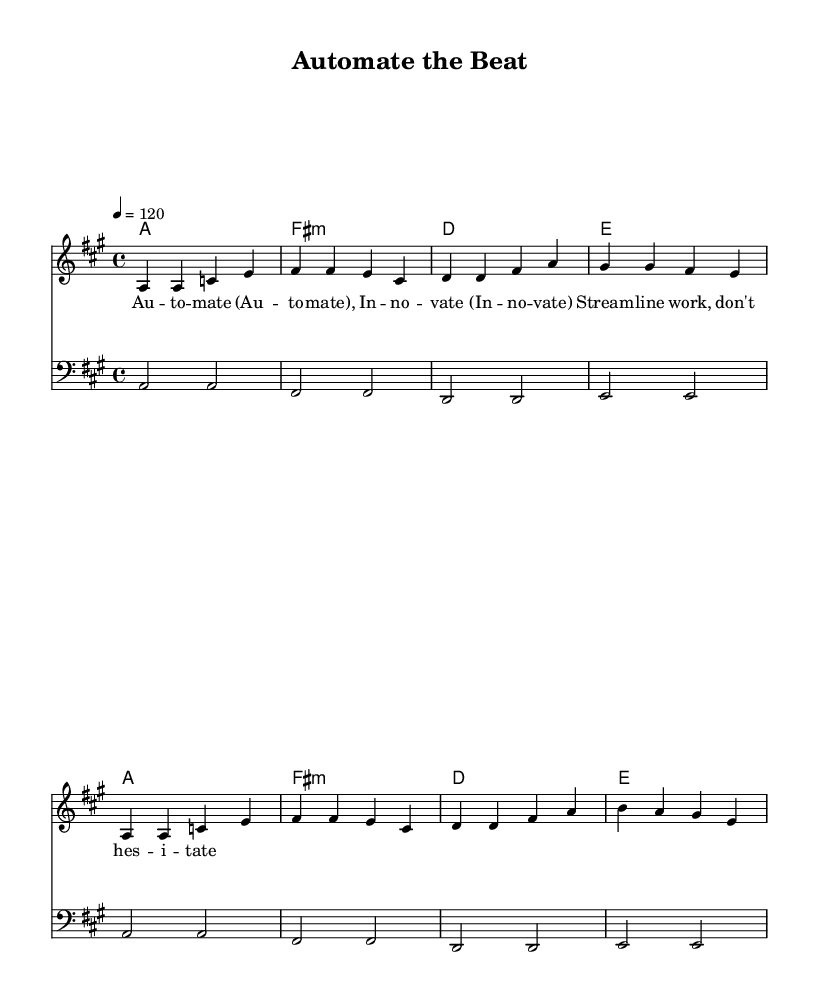What is the key signature of this music? The key signature is indicated by the notes present. In this case, the key of A major contains three sharps: F#, C#, and G#. Therefore, we conclude that the key signature is A major.
Answer: A major What is the time signature of this music? The time signature is typically found at the beginning of the score, written as a fraction. Here, it is shown as 4/4, meaning there are four beats per measure.
Answer: 4/4 What tempo marking is used in this music? The tempo is given in beats per minute, indicated in the score as a number. In this case, the tempo marking is 120, meaning the music should be played at 120 beats per minute.
Answer: 120 How many measures are in the melody section? To find the number of measures, we count the divisions between vertical lines in the melody. There are a total of 8 measures in the melody part of the score.
Answer: 8 Which chord appears first in the harmony section? The harmony section lists the chords, starting with the first one placed in the first measure. The first chord is A major, as indicated by the symbol at the start of the score.
Answer: A What word describes the overall theme of this disco song? The words presented in the lyric section hint at the subject of the song, focusing on themes of automation and innovation. Therefore, the theme of this song can be summarized as "automation."
Answer: automation What is the role of the bass in this piece? The bass typically plays a fundamental role in providing the harmonic foundation in music. In this piece, the bass lines correspond with the harmony chords, reinforcing the rhythm and harmony. Thus, the role of the bass is to support the harmonic structure.
Answer: support 